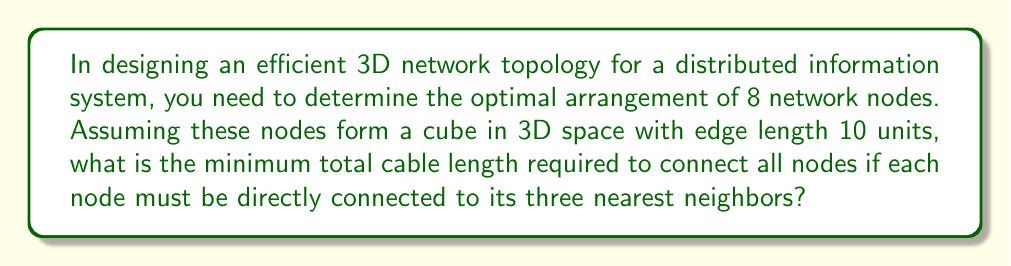Can you solve this math problem? Let's approach this step-by-step:

1) In a cube, each vertex (node) has three nearest neighbors, which are the vertices connected by the edges meeting at that vertex.

2) The number of edges in a cube is 12. Each edge represents a cable connection between two nodes.

3) The length of each edge is given as 10 units.

4) To calculate the total cable length, we need to sum up the lengths of all edges:

   Total cable length = Number of edges × Length of each edge
   $$ \text{Total cable length} = 12 \times 10 = 120 \text{ units} $$

5) This arrangement ensures that each node is directly connected to its three nearest neighbors, as required.

6) To verify this is the minimum total cable length:
   - Any other arrangement connecting each node to three others would require longer cables (e.g., connecting across diagonals).
   - Connecting to fewer than three neighbors per node would not satisfy the problem requirements.

Therefore, the cube arrangement with edge length 10 units provides the optimal (minimum) total cable length while meeting all requirements.
Answer: 120 units 